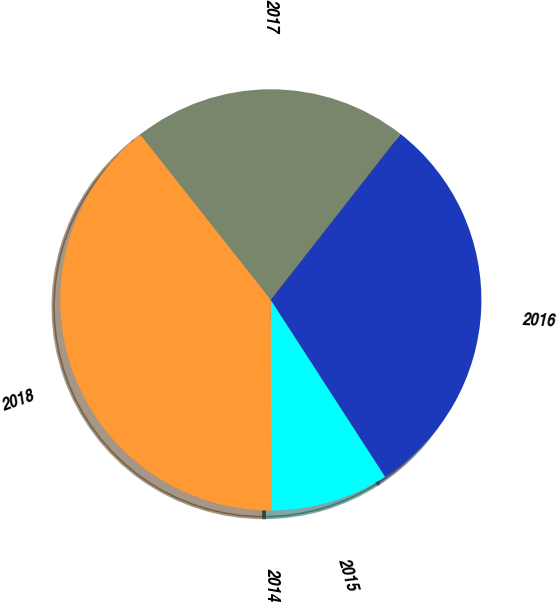Convert chart. <chart><loc_0><loc_0><loc_500><loc_500><pie_chart><fcel>2014<fcel>2015<fcel>2016<fcel>2017<fcel>2018<nl><fcel>0.01%<fcel>9.1%<fcel>30.3%<fcel>21.21%<fcel>39.38%<nl></chart> 